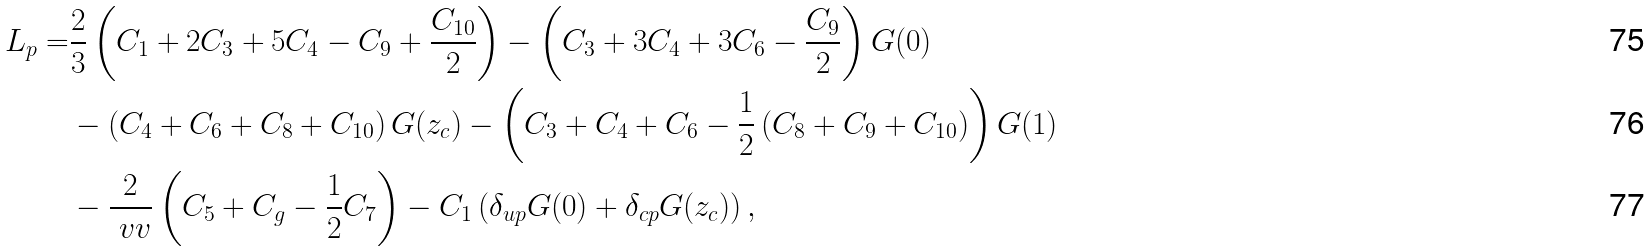<formula> <loc_0><loc_0><loc_500><loc_500>L _ { p } = & \frac { 2 } { 3 } \left ( C _ { 1 } + 2 C _ { 3 } + 5 C _ { 4 } - C _ { 9 } + \frac { C _ { 1 0 } } { 2 } \right ) - \left ( C _ { 3 } + 3 C _ { 4 } + 3 C _ { 6 } - \frac { C _ { 9 } } { 2 } \right ) G ( 0 ) \\ & - \left ( C _ { 4 } + C _ { 6 } + C _ { 8 } + C _ { 1 0 } \right ) G ( z _ { c } ) - \left ( C _ { 3 } + C _ { 4 } + C _ { 6 } - \frac { 1 } { 2 } \left ( C _ { 8 } + C _ { 9 } + C _ { 1 0 } \right ) \right ) G ( 1 ) \\ & - \frac { 2 } { \ v v } \left ( C _ { 5 } + C _ { g } - \frac { 1 } { 2 } C _ { 7 } \right ) - C _ { 1 } \left ( \delta _ { u p } G ( 0 ) + \delta _ { c p } G ( z _ { c } ) \right ) ,</formula> 